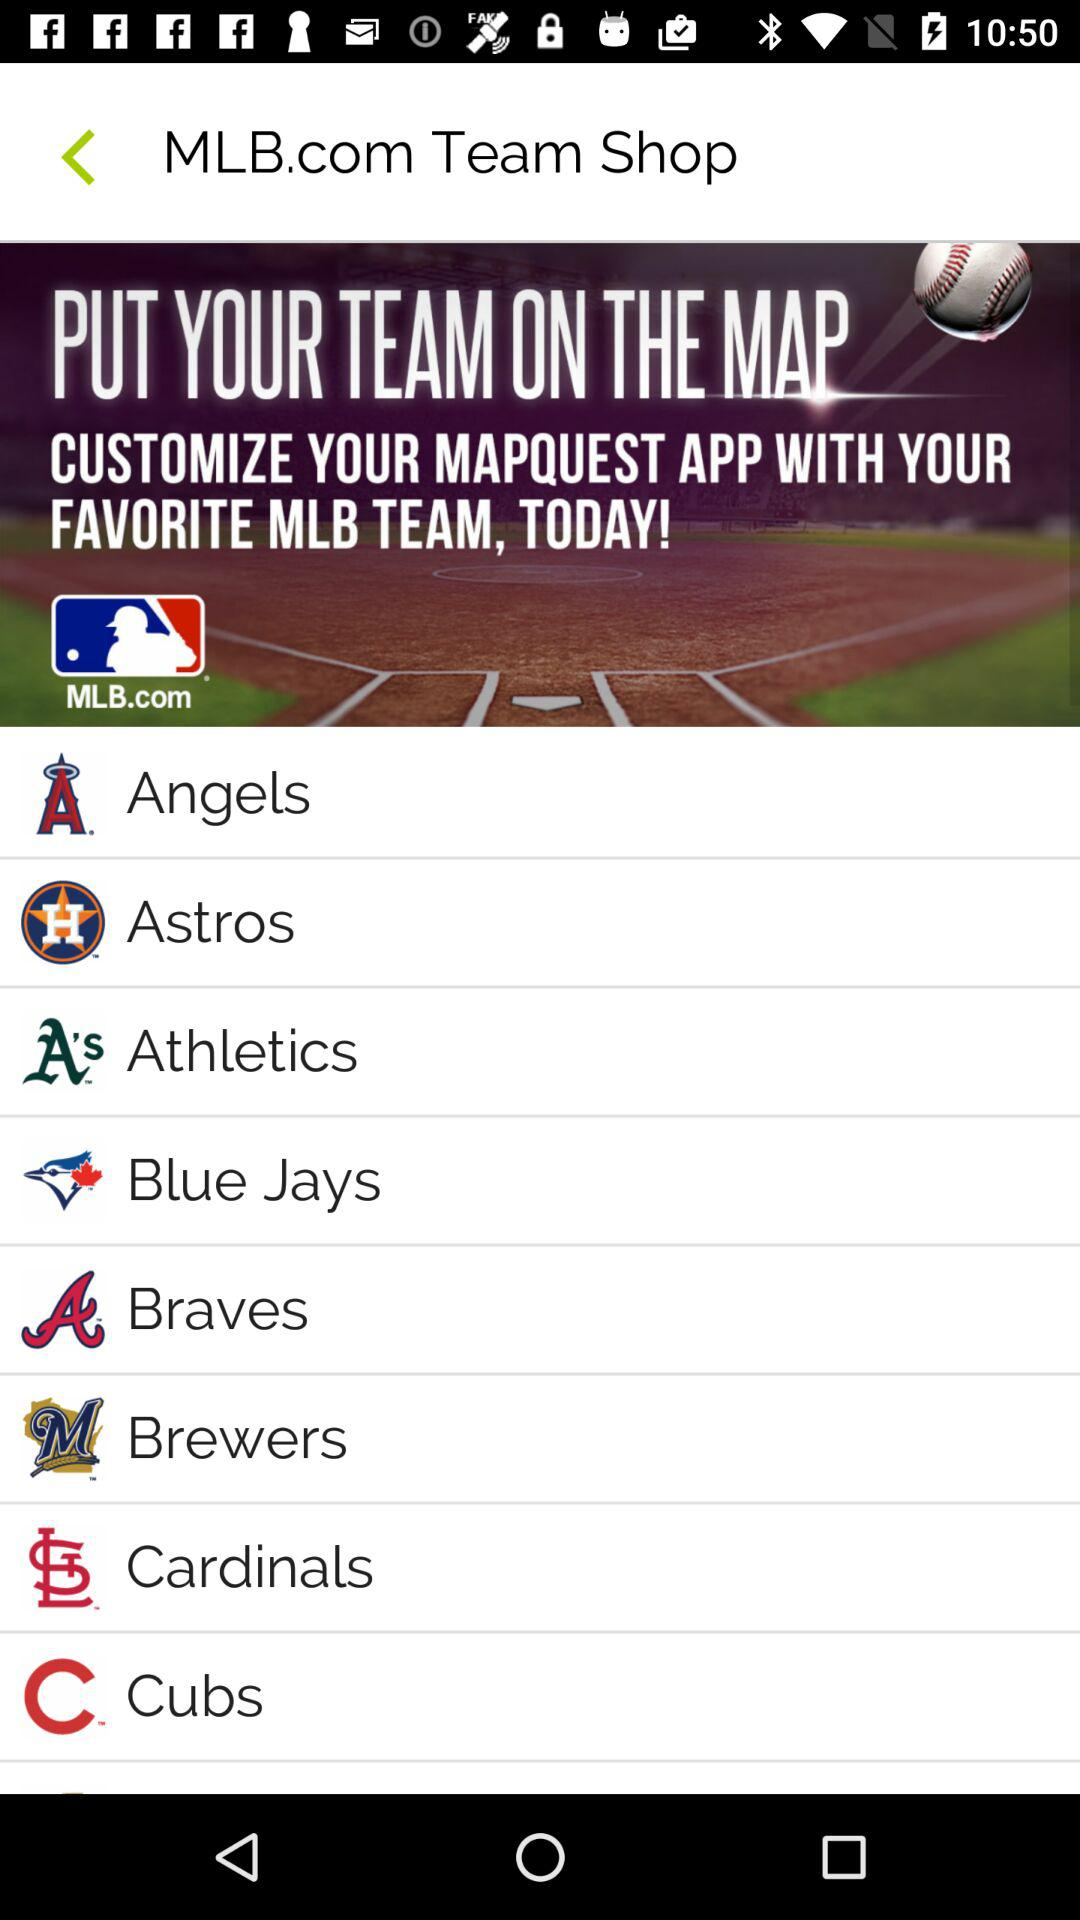What is the name of the application? The name of the application is "MLB.com". 